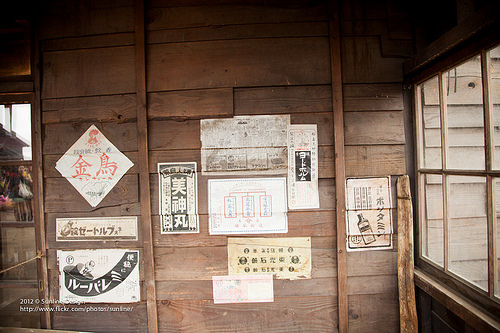<image>
Can you confirm if the window is to the left of the door? No. The window is not to the left of the door. From this viewpoint, they have a different horizontal relationship. 